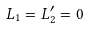<formula> <loc_0><loc_0><loc_500><loc_500>L _ { 1 } = L _ { 2 } ^ { \prime } = 0</formula> 